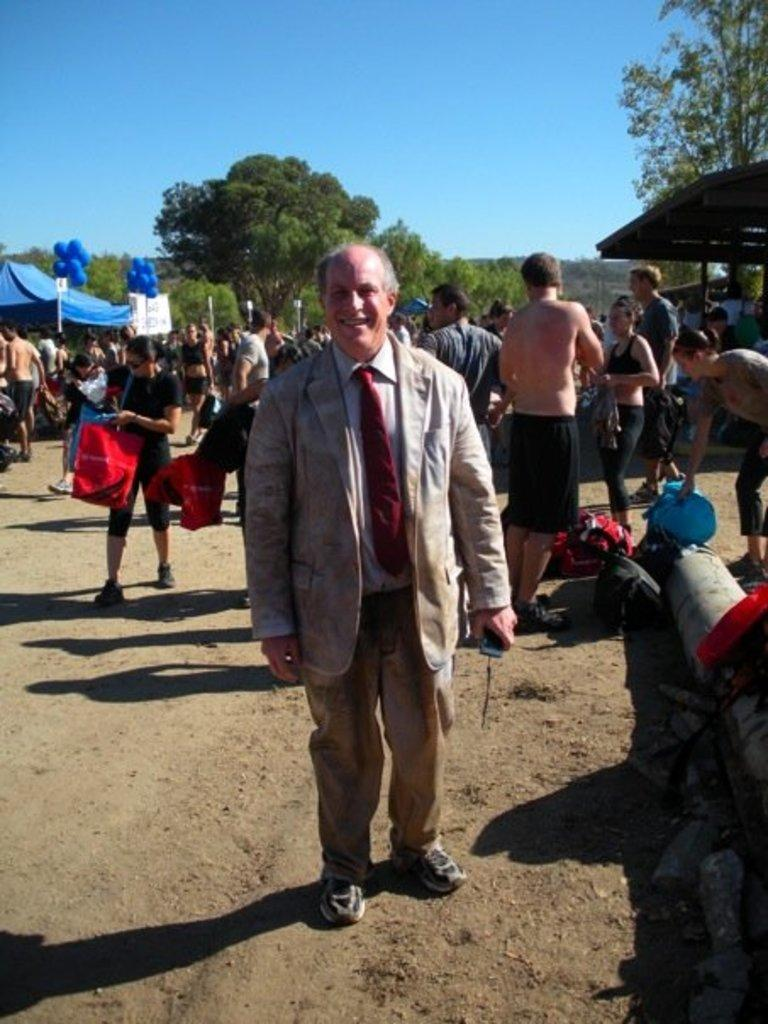What is the person in the image wearing? The person is wearing a suit. What is the person's facial expression in the image? The person is smiling. What is the person holding in the image? The person is holding an object. Can you describe the background of the image? There are people, tents, balloons, and trees in the background. What type of legal advice is the person providing in the image? There is no indication in the image that the person is a lawyer or providing legal advice. 